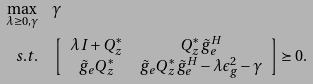Convert formula to latex. <formula><loc_0><loc_0><loc_500><loc_500>\max _ { \lambda \geq 0 , \gamma } & \quad \gamma \\ { s . t . } & \quad \left [ \begin{array} { c c } \lambda I + Q _ { z } ^ { * } & Q _ { z } ^ { * } \tilde { g } _ { e } ^ { H } \\ \tilde { g } _ { e } Q _ { z } ^ { * } & \tilde { g } _ { e } Q _ { z } ^ { * } \tilde { g } _ { e } ^ { H } - \lambda \epsilon _ { g } ^ { 2 } - \gamma \end{array} \right ] \succeq 0 .</formula> 